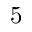Convert formula to latex. <formula><loc_0><loc_0><loc_500><loc_500>5</formula> 